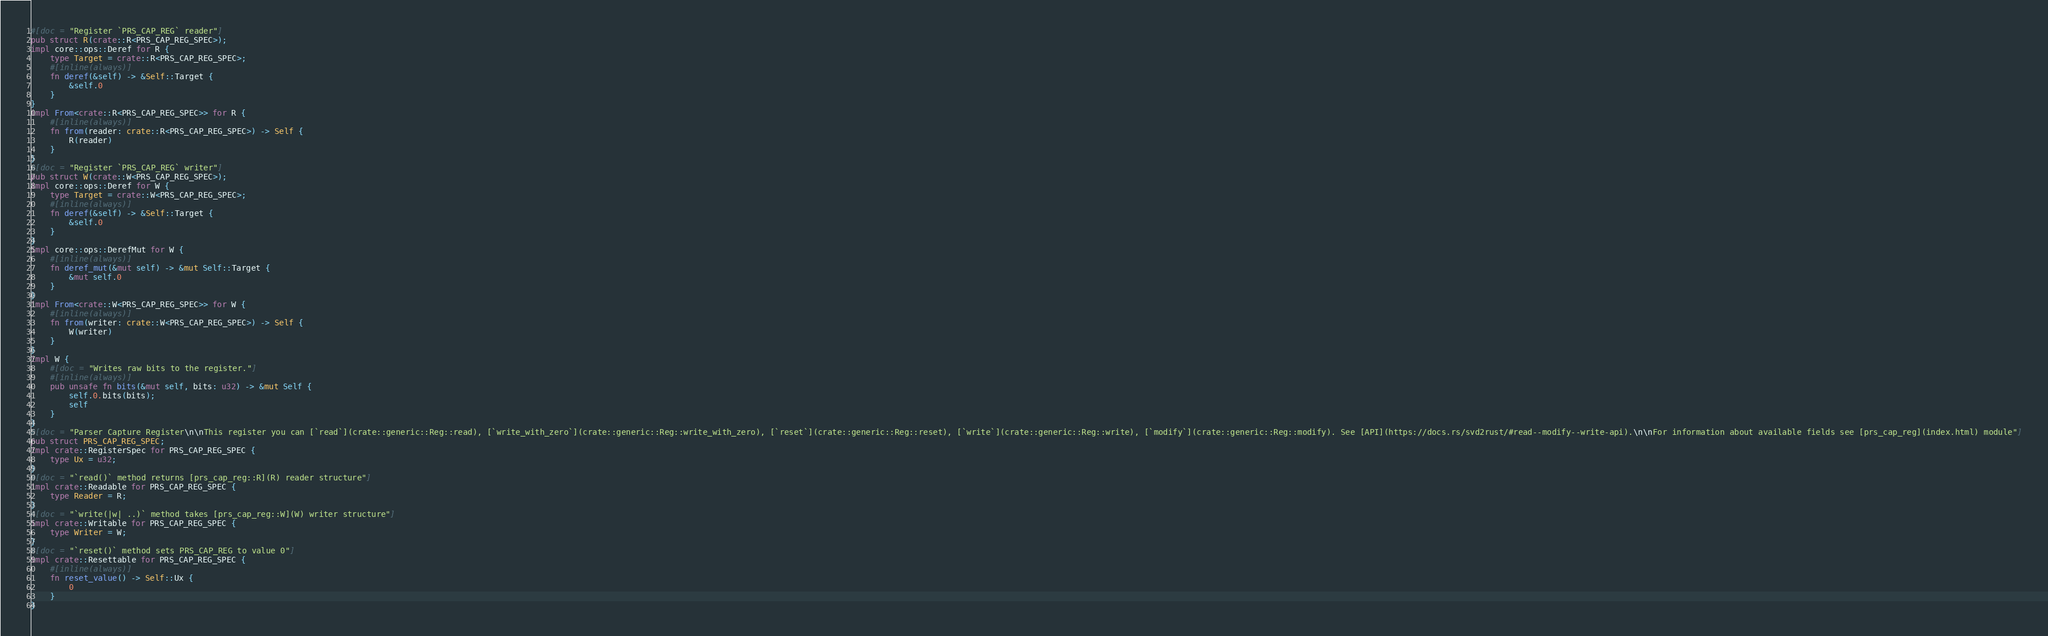<code> <loc_0><loc_0><loc_500><loc_500><_Rust_>#[doc = "Register `PRS_CAP_REG` reader"]
pub struct R(crate::R<PRS_CAP_REG_SPEC>);
impl core::ops::Deref for R {
    type Target = crate::R<PRS_CAP_REG_SPEC>;
    #[inline(always)]
    fn deref(&self) -> &Self::Target {
        &self.0
    }
}
impl From<crate::R<PRS_CAP_REG_SPEC>> for R {
    #[inline(always)]
    fn from(reader: crate::R<PRS_CAP_REG_SPEC>) -> Self {
        R(reader)
    }
}
#[doc = "Register `PRS_CAP_REG` writer"]
pub struct W(crate::W<PRS_CAP_REG_SPEC>);
impl core::ops::Deref for W {
    type Target = crate::W<PRS_CAP_REG_SPEC>;
    #[inline(always)]
    fn deref(&self) -> &Self::Target {
        &self.0
    }
}
impl core::ops::DerefMut for W {
    #[inline(always)]
    fn deref_mut(&mut self) -> &mut Self::Target {
        &mut self.0
    }
}
impl From<crate::W<PRS_CAP_REG_SPEC>> for W {
    #[inline(always)]
    fn from(writer: crate::W<PRS_CAP_REG_SPEC>) -> Self {
        W(writer)
    }
}
impl W {
    #[doc = "Writes raw bits to the register."]
    #[inline(always)]
    pub unsafe fn bits(&mut self, bits: u32) -> &mut Self {
        self.0.bits(bits);
        self
    }
}
#[doc = "Parser Capture Register\n\nThis register you can [`read`](crate::generic::Reg::read), [`write_with_zero`](crate::generic::Reg::write_with_zero), [`reset`](crate::generic::Reg::reset), [`write`](crate::generic::Reg::write), [`modify`](crate::generic::Reg::modify). See [API](https://docs.rs/svd2rust/#read--modify--write-api).\n\nFor information about available fields see [prs_cap_reg](index.html) module"]
pub struct PRS_CAP_REG_SPEC;
impl crate::RegisterSpec for PRS_CAP_REG_SPEC {
    type Ux = u32;
}
#[doc = "`read()` method returns [prs_cap_reg::R](R) reader structure"]
impl crate::Readable for PRS_CAP_REG_SPEC {
    type Reader = R;
}
#[doc = "`write(|w| ..)` method takes [prs_cap_reg::W](W) writer structure"]
impl crate::Writable for PRS_CAP_REG_SPEC {
    type Writer = W;
}
#[doc = "`reset()` method sets PRS_CAP_REG to value 0"]
impl crate::Resettable for PRS_CAP_REG_SPEC {
    #[inline(always)]
    fn reset_value() -> Self::Ux {
        0
    }
}
</code> 